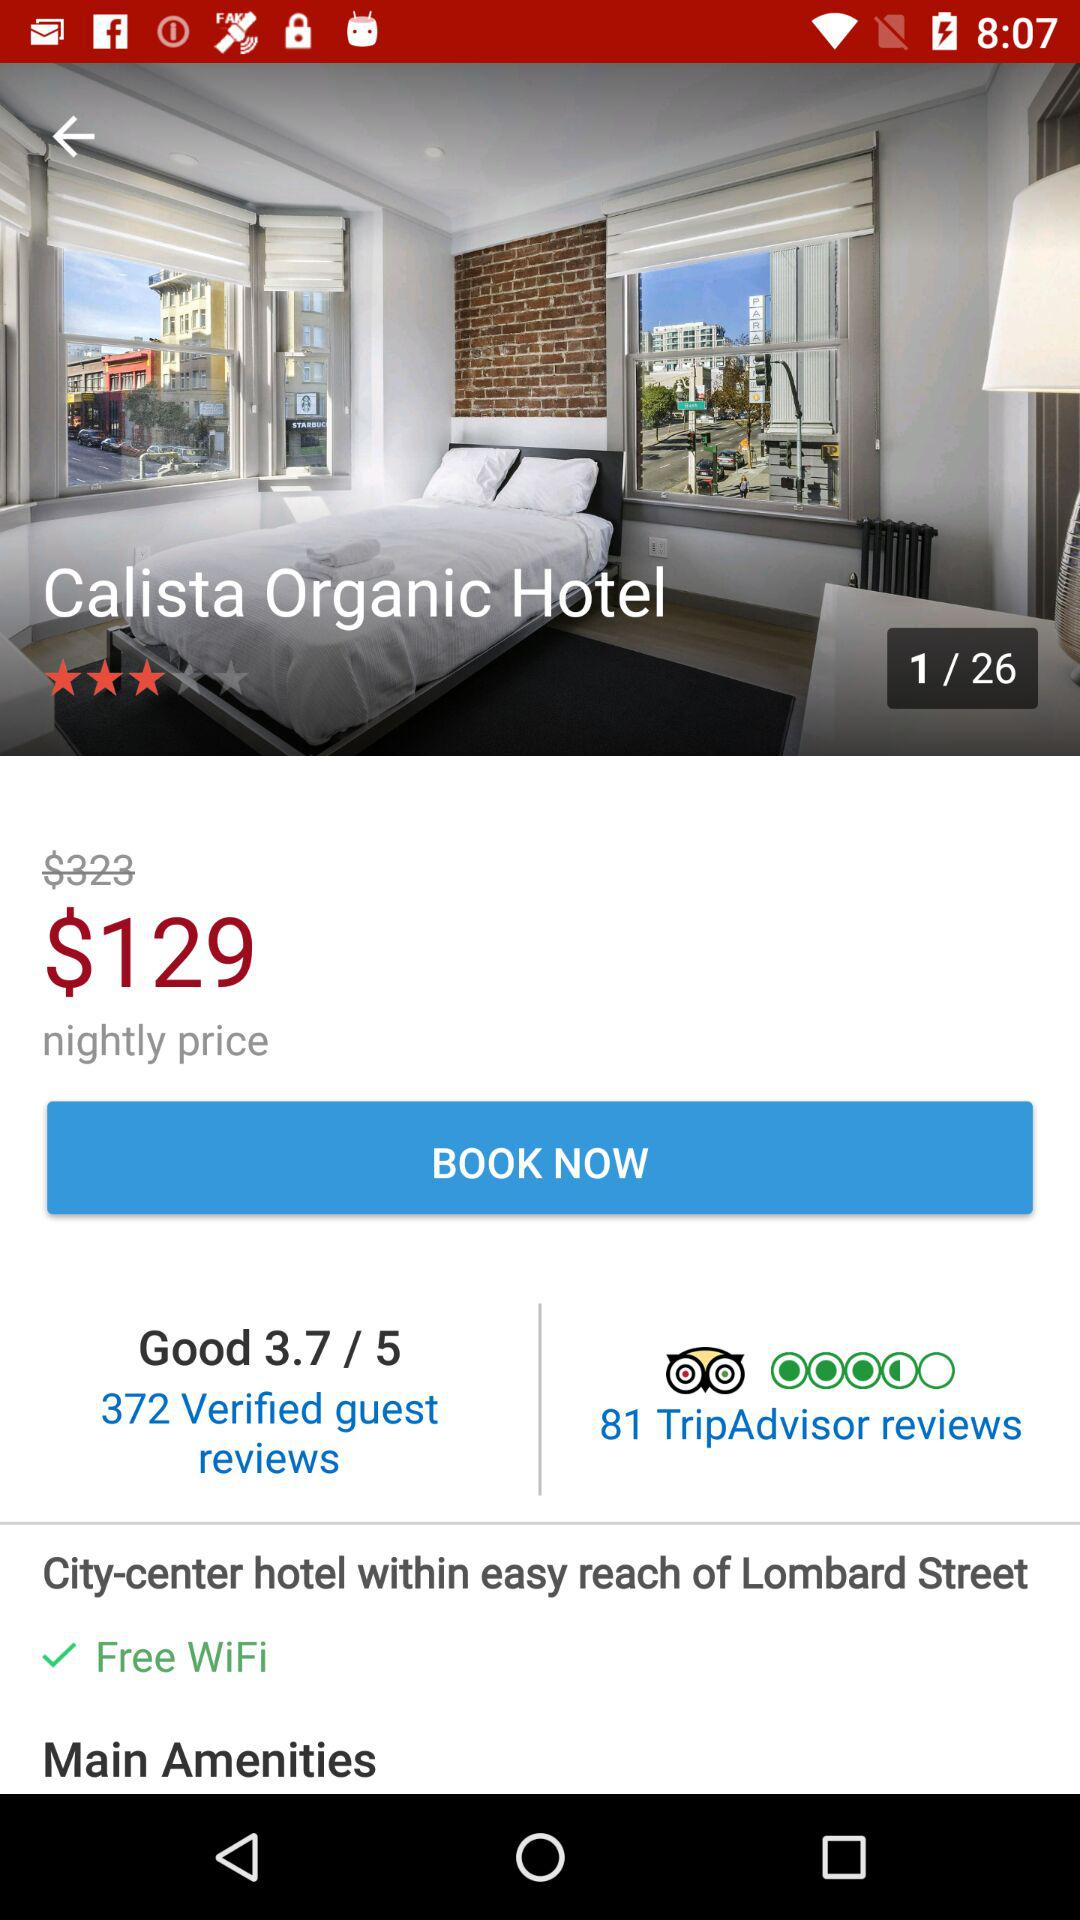Which page number are we on currently? You are currently on page number 1. 